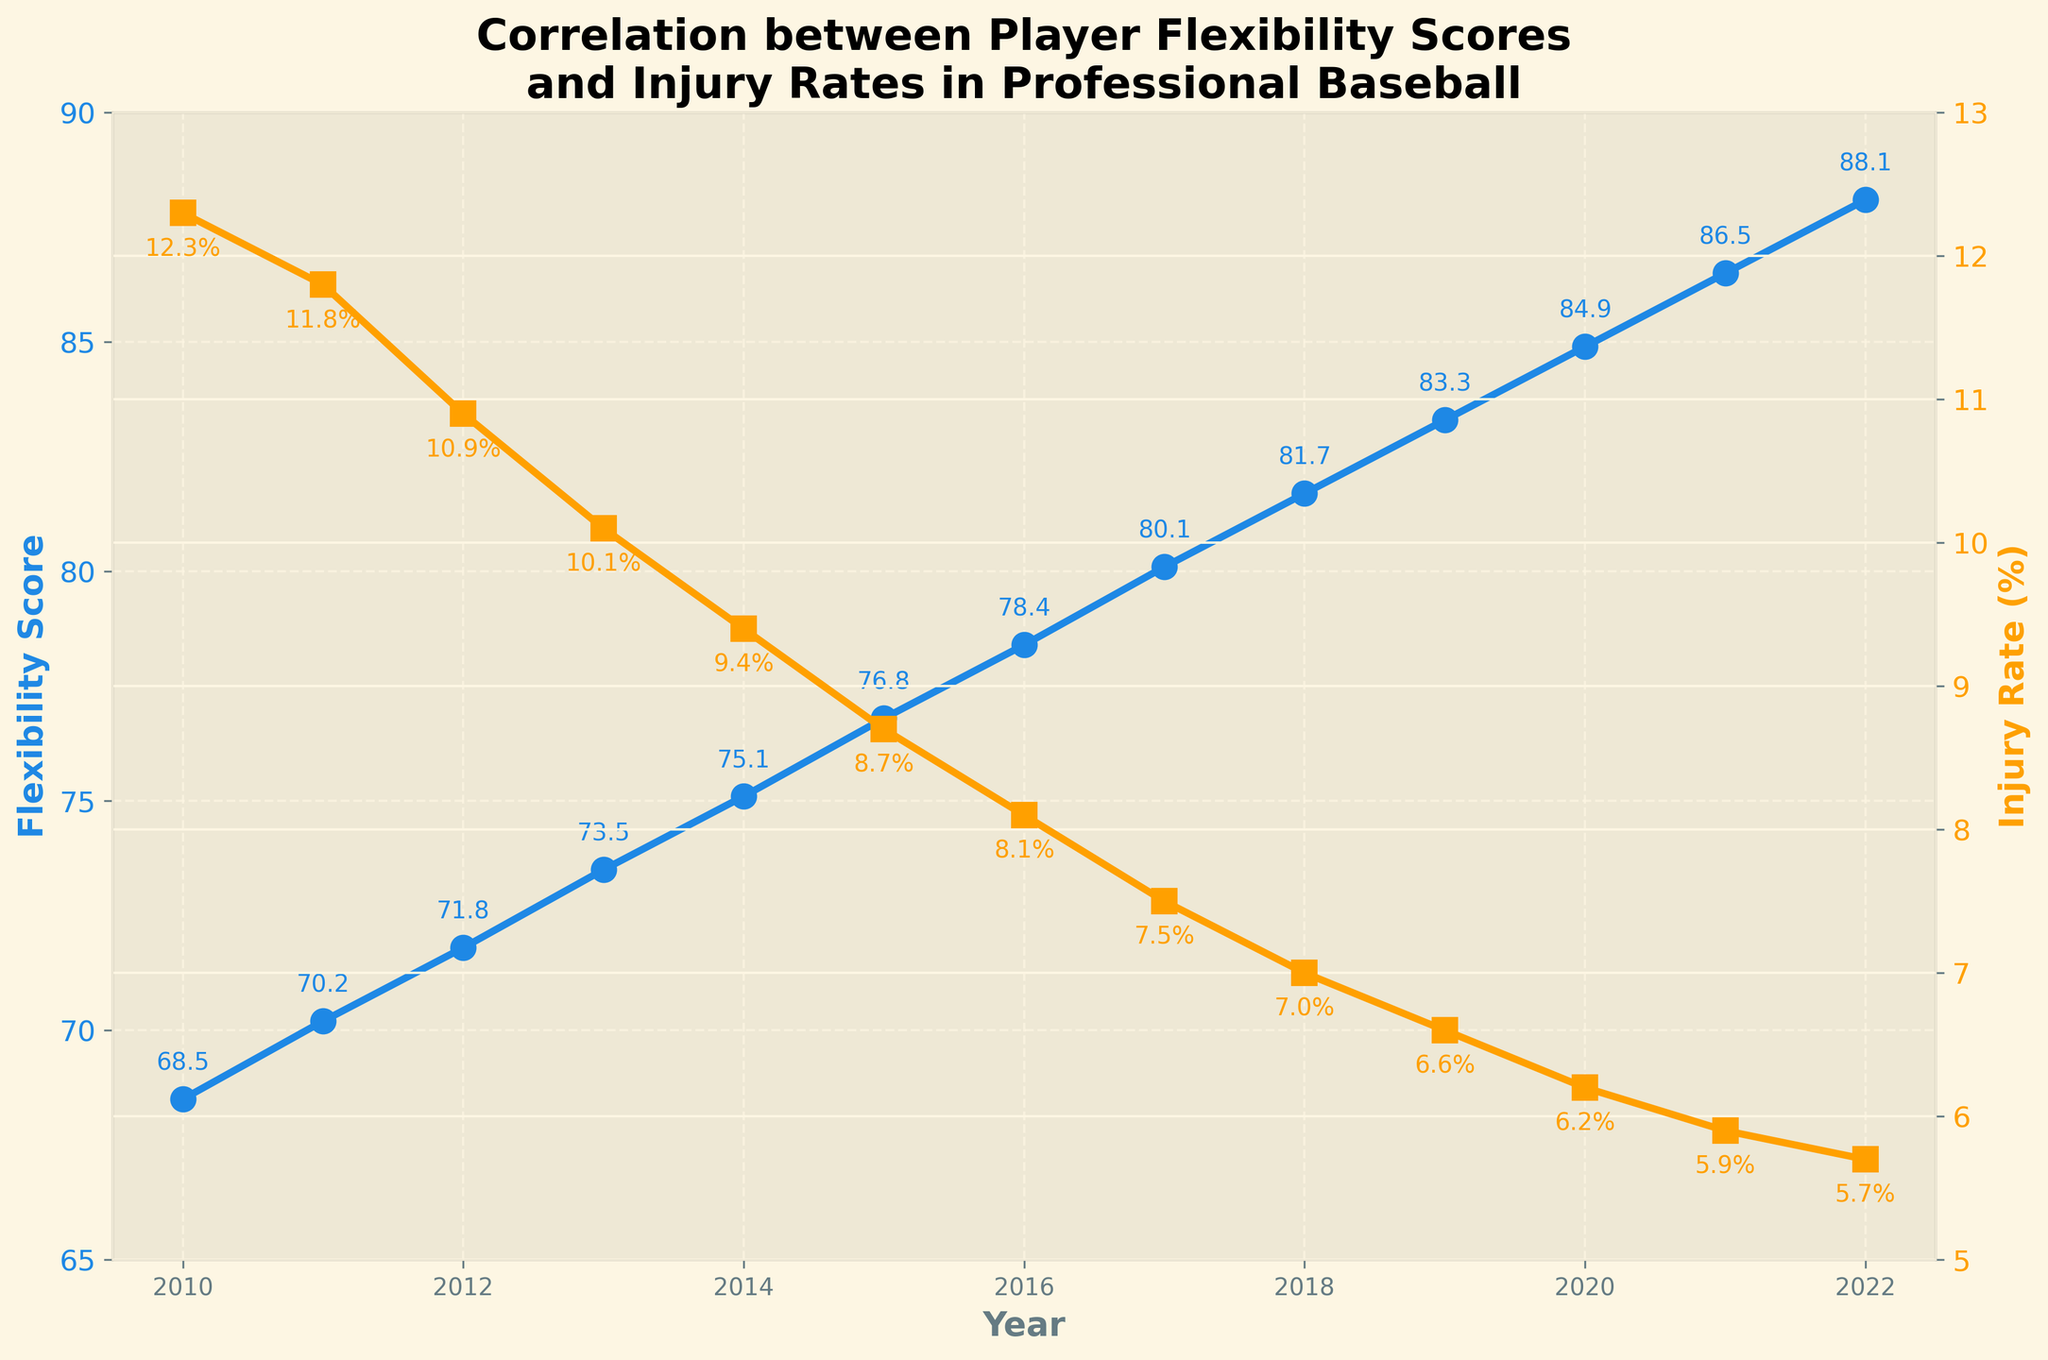what is the trend of flexibility scores over time? The flexibility scores increase steadily every year from 2010 to 2022, showing a consistent improvement in the players' flexibility over this period.
Answer: Increasing trend how did the injury rate change from 2010 to 2013? The injury rate decreased from 12.3% in 2010 to 10.1% in 2013. To find this, look at the injury rate values for the two years and note the decrease over time.
Answer: Decreased how do the flexibility scores and injury rates compare in 2020? In 2020, the flexibility score is 84.9, and the injury rate is 6.2%. Compare these values directly to observe the data points for this year.
Answer: Flexibility: 84.9, Injury Rate: 6.2% which year had the highest flexibility score and what was it? By examining the flexibility scores over the years, the highest flexibility score recorded is 88.1 in 2022.
Answer: 2022, 88.1 what is the average flexibility score between 2015 and 2020? The scores between 2015 and 2020 are 76.8, 78.4, 80.1, 81.7, 83.3, and 84.9. Summing these values gives 485.2, and dividing by 6 gives an average of approximately 80.87.
Answer: 80.87 in which year was the largest drop in injury rate observed, and what was the drop? The most considerable drop was between 2018 and 2019, decreasing from 7.0% to 6.6%. The drop is 7.0 - 6.6 = 0.4%.
Answer: 2018 to 2019, 0.4% are the trends of flexibility scores and injury rates positively or negatively correlated? The flexibility scores increase while the injury rates decrease, indicating a negative correlation. One goes up as the other goes down.
Answer: Negatively correlated how does the injury rate in 2022 compare to that in 2010? The injury rate in 2022 is 5.7%, and in 2010, it was 12.3%. The injury rate has significantly decreased over this period by 12.3 - 5.7 = 6.6%.
Answer: Decreased by 6.6% what is the median value of the injury rates from 2011 to 2016? The injury rates from 2011 to 2016 are 11.8, 10.9, 10.1, 9.4, 8.7, 8.1. Arranging them in ascending order: 8.1, 8.7, 9.4, 10.1, 10.9, 11.8, the median is the average of the two middle values: (9.4 + 10.1)/2 = 9.75%.
Answer: 9.75% what is the change in flexibility score from 2010 to the last recorded year? The flexibility score increases from 68.5 in 2010 to 88.1 in 2022. The change is 88.1 - 68.5 = 19.6.
Answer: 19.6 